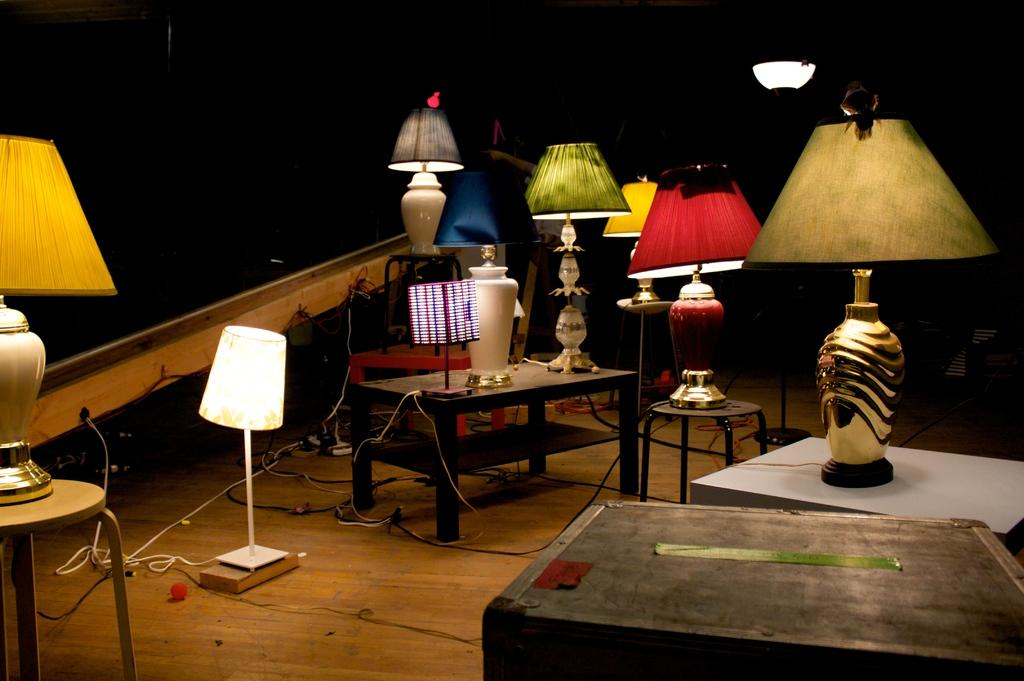What type of furniture is present in the image? There are tables in the image. What objects provide lighting in the image? There are lamps in the image. What can be seen on the floor in the image? There are wires on the floor in the image. How would you describe the overall lighting in the image? The background of the image is dark in color, which suggests that the image may have been taken during the night in a room. Can you tell me how many donkeys are visible in the image? There are no donkeys present in the image. What type of metal is used to make the shelf in the image? There is no shelf present in the image. 